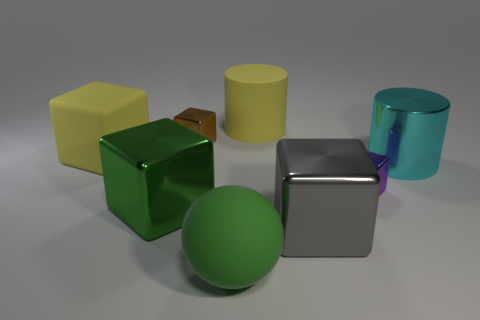Subtract 1 cubes. How many cubes are left? 4 Subtract all red blocks. Subtract all cyan cylinders. How many blocks are left? 5 Add 1 small green metal cylinders. How many objects exist? 9 Subtract all cylinders. How many objects are left? 6 Add 2 small purple blocks. How many small purple blocks exist? 3 Subtract 0 brown cylinders. How many objects are left? 8 Subtract all tiny yellow cylinders. Subtract all purple cubes. How many objects are left? 7 Add 7 large gray objects. How many large gray objects are left? 8 